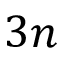<formula> <loc_0><loc_0><loc_500><loc_500>3 n</formula> 